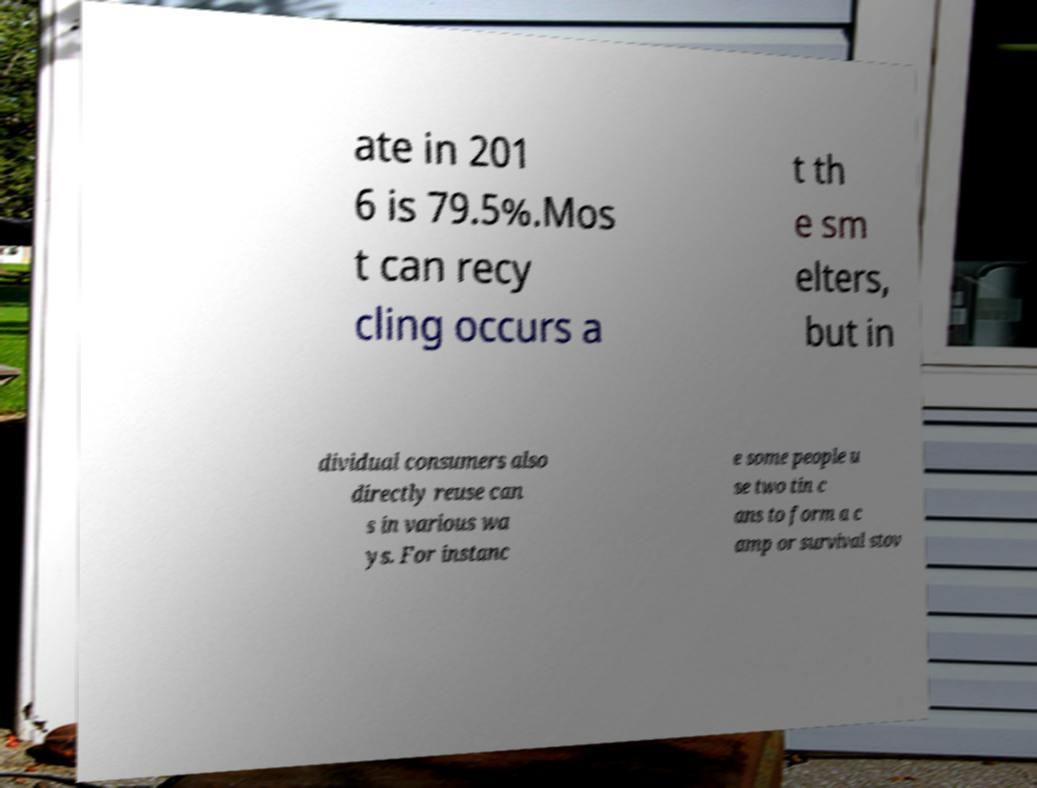Could you assist in decoding the text presented in this image and type it out clearly? ate in 201 6 is 79.5%.Mos t can recy cling occurs a t th e sm elters, but in dividual consumers also directly reuse can s in various wa ys. For instanc e some people u se two tin c ans to form a c amp or survival stov 